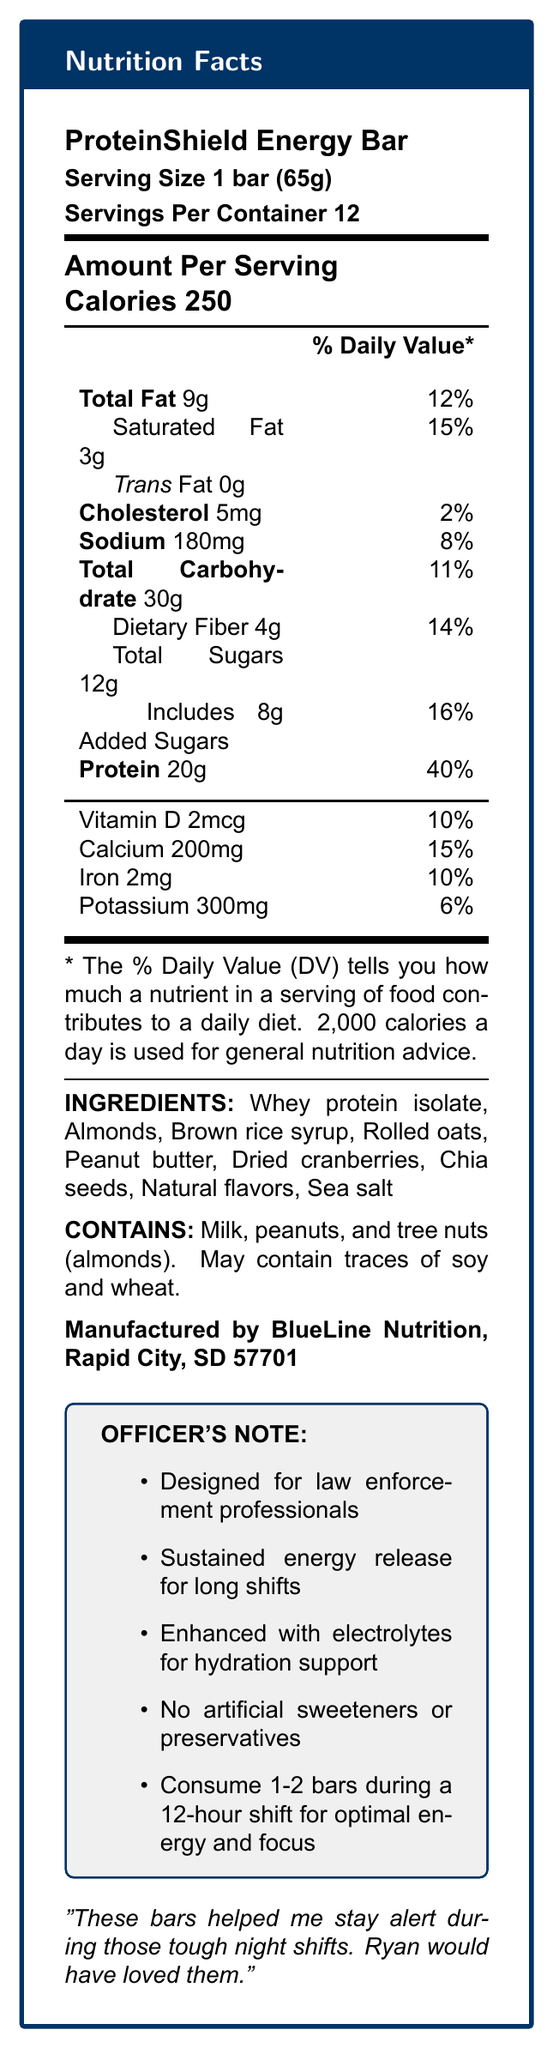what is the product name? The product name is prominently displayed at the top of the document.
Answer: ProteinShield Energy Bar what is the serving size of the ProteinShield Energy Bar? The serving size is listed below the product name.
Answer: 1 bar (65g) how many servings are in one container? The document specifies that there are 12 servings per container.
Answer: 12 how many calories are in one serving? The amount of calories per serving is indicated in the "Amount Per Serving" section.
Answer: 250 what is the amount of protein per serving? The protein content per serving is displayed in the nutritional information section.
Answer: 20g how many grams of total sugars does one bar contain? The document lists the total sugars in the nutritional information.
Answer: 12g how much sodium does a serving contain? The sodium content is listed under the nutritional section.
Answer: 180mg what percentage of the daily value of calcium does one bar provide? This information is provided in the vitamin and mineral breakdown.
Answer: 15% how much added sugar is in each bar? The document specifies 8g of added sugars in one bar.
Answer: 8g what ingredients are used in the ProteinShield Energy Bar? The ingredients are listed towards the end of the document.
Answer: Whey protein isolate, Almonds, Brown rice syrup, Rolled oats, Peanut butter, Dried cranberries, Chia seeds, Natural flavors, Sea salt which of the following does the ProteinShield Energy Bar not contain? A. Trans Fat B. Dietary Fiber C. Vitamin D D. Iron The document specifies that the bar contains 0g of trans fat.
Answer: A how much potassium does each bar provide? A. 250mg B. 200mg C. 350mg D. 300mg The potassium content per serving is listed as 300mg.
Answer: D is the ProteinShield Energy Bar free of artificial sweeteners and preservatives? The special features mention that the bar contains no artificial sweeteners or preservatives.
Answer: Yes is there any warning for allergens in the document? The document mentions that the bar contains milk, peanuts, and tree nuts (almonds), and may contain traces of soy and wheat.
Answer: Yes how is the ProteinShield Energy Bar specifically beneficial for law enforcement professionals? The special features box highlights these benefits.
Answer: Designed for law enforcement professionals, provides sustained energy release for long shifts, enhanced with electrolytes for hydration support what is the officer's testimonial included in the document? The testimonial is cited at the end of the document.
Answer: "These bars helped me stay alert during those tough night shifts. Ryan would have loved them." what are the recommended consumption guidelines for long shifts? The recommendation is mentioned in the special features box.
Answer: Consume 1-2 bars during a 12-hour shift for optimal energy and focus. what percentage of daily value of iron does one bar contain? This information is listed in the vitamin and mineral breakdown.
Answer: 10% who is the manufacturer of the ProteinShield Energy Bar? The manufacturer's information is listed at the end of the document.
Answer: BlueLine Nutrition, Rapid City, SD 57701 what is the reason for producing the ProteinShield Energy Bar? The document does not provide specific information on why the bar was produced, although it highlights features useful to law enforcement officers.
Answer: Cannot be determined describe the main idea of the document. The document delivers comprehensive insights into the nutritional value of the ProteinShield Energy Bar, emphasizing its benefits for law enforcement professionals during long shifts.
Answer: The document provides detailed nutritional information about the ProteinShield Energy Bar, designed for law enforcement professionals. It includes serving size, calories, macronutrients, vitamins, minerals, ingredients, allergen information, and the manufacturer. Special features like sustained energy release, electrolyte enhancement, and a testimonial from an officer are also highlighted. 